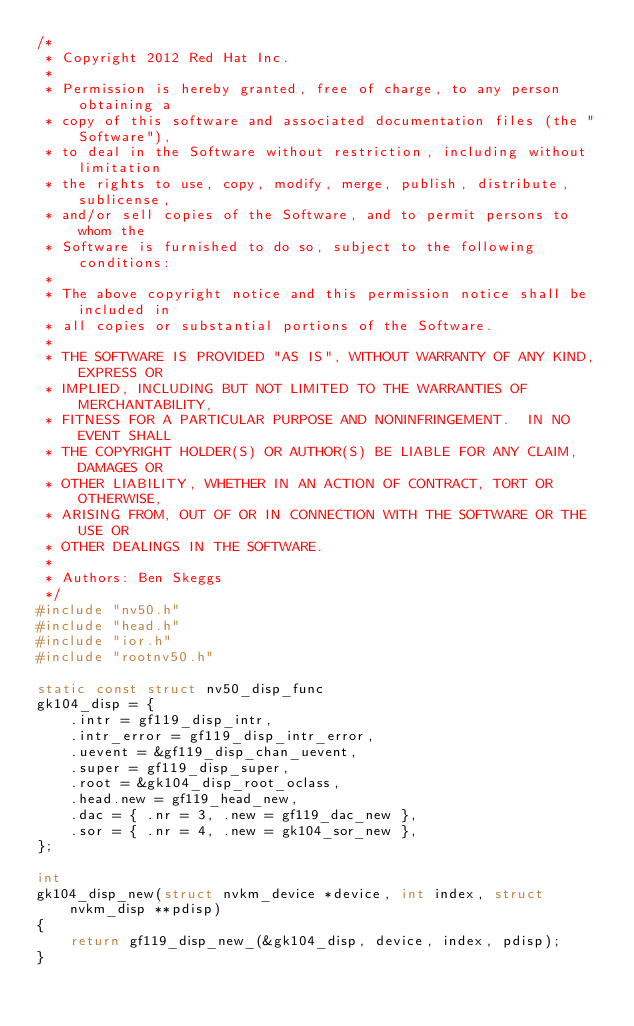Convert code to text. <code><loc_0><loc_0><loc_500><loc_500><_C_>/*
 * Copyright 2012 Red Hat Inc.
 *
 * Permission is hereby granted, free of charge, to any person obtaining a
 * copy of this software and associated documentation files (the "Software"),
 * to deal in the Software without restriction, including without limitation
 * the rights to use, copy, modify, merge, publish, distribute, sublicense,
 * and/or sell copies of the Software, and to permit persons to whom the
 * Software is furnished to do so, subject to the following conditions:
 *
 * The above copyright notice and this permission notice shall be included in
 * all copies or substantial portions of the Software.
 *
 * THE SOFTWARE IS PROVIDED "AS IS", WITHOUT WARRANTY OF ANY KIND, EXPRESS OR
 * IMPLIED, INCLUDING BUT NOT LIMITED TO THE WARRANTIES OF MERCHANTABILITY,
 * FITNESS FOR A PARTICULAR PURPOSE AND NONINFRINGEMENT.  IN NO EVENT SHALL
 * THE COPYRIGHT HOLDER(S) OR AUTHOR(S) BE LIABLE FOR ANY CLAIM, DAMAGES OR
 * OTHER LIABILITY, WHETHER IN AN ACTION OF CONTRACT, TORT OR OTHERWISE,
 * ARISING FROM, OUT OF OR IN CONNECTION WITH THE SOFTWARE OR THE USE OR
 * OTHER DEALINGS IN THE SOFTWARE.
 *
 * Authors: Ben Skeggs
 */
#include "nv50.h"
#include "head.h"
#include "ior.h"
#include "rootnv50.h"

static const struct nv50_disp_func
gk104_disp = {
	.intr = gf119_disp_intr,
	.intr_error = gf119_disp_intr_error,
	.uevent = &gf119_disp_chan_uevent,
	.super = gf119_disp_super,
	.root = &gk104_disp_root_oclass,
	.head.new = gf119_head_new,
	.dac = { .nr = 3, .new = gf119_dac_new },
	.sor = { .nr = 4, .new = gk104_sor_new },
};

int
gk104_disp_new(struct nvkm_device *device, int index, struct nvkm_disp **pdisp)
{
	return gf119_disp_new_(&gk104_disp, device, index, pdisp);
}
</code> 